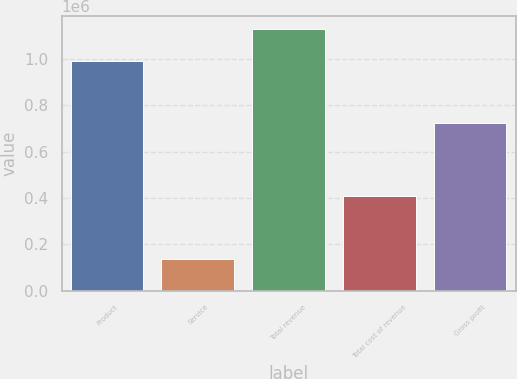Convert chart. <chart><loc_0><loc_0><loc_500><loc_500><bar_chart><fcel>Product<fcel>Service<fcel>Total revenue<fcel>Total cost of revenue<fcel>Gross profit<nl><fcel>991337<fcel>137830<fcel>1.12917e+06<fcel>406051<fcel>723116<nl></chart> 